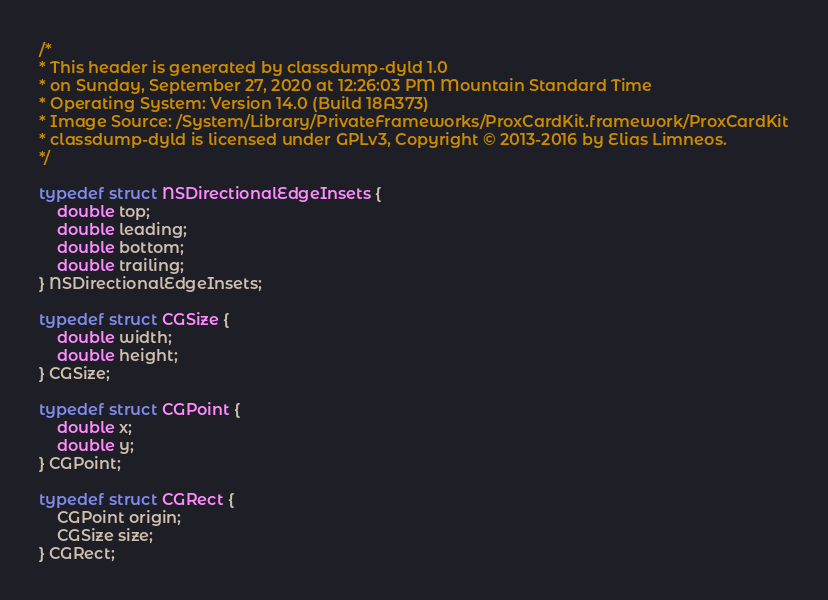<code> <loc_0><loc_0><loc_500><loc_500><_C_>/*
* This header is generated by classdump-dyld 1.0
* on Sunday, September 27, 2020 at 12:26:03 PM Mountain Standard Time
* Operating System: Version 14.0 (Build 18A373)
* Image Source: /System/Library/PrivateFrameworks/ProxCardKit.framework/ProxCardKit
* classdump-dyld is licensed under GPLv3, Copyright © 2013-2016 by Elias Limneos.
*/

typedef struct NSDirectionalEdgeInsets {
	double top;
	double leading;
	double bottom;
	double trailing;
} NSDirectionalEdgeInsets;

typedef struct CGSize {
	double width;
	double height;
} CGSize;

typedef struct CGPoint {
	double x;
	double y;
} CGPoint;

typedef struct CGRect {
	CGPoint origin;
	CGSize size;
} CGRect;

</code> 